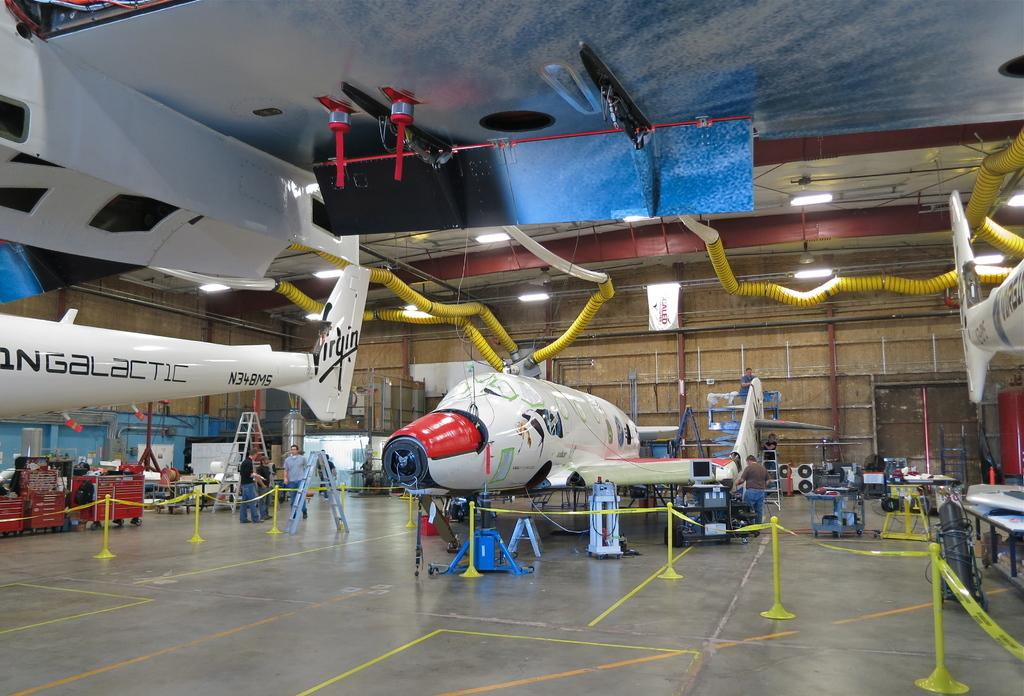<image>
Render a clear and concise summary of the photo. Large Galactic airplanes on display inside a building. 